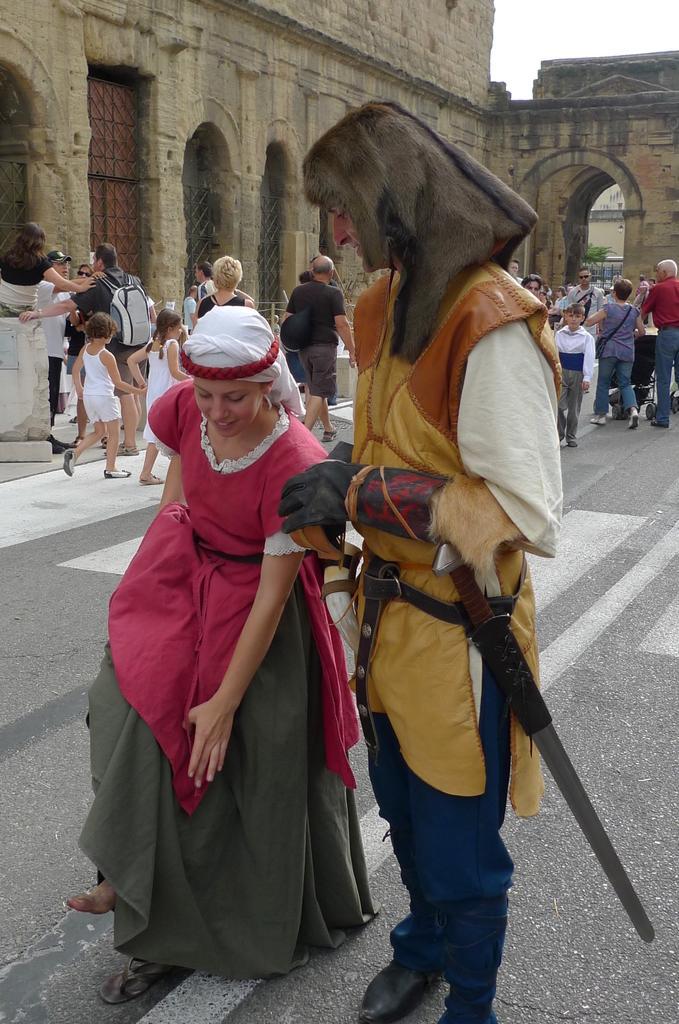Can you describe this image briefly? In this image, we can see two persons wearing costumes and standing on the road. In the background, we can see the people, fort, walls, grilles, some objects and the sky. Few people are holding some objects. 